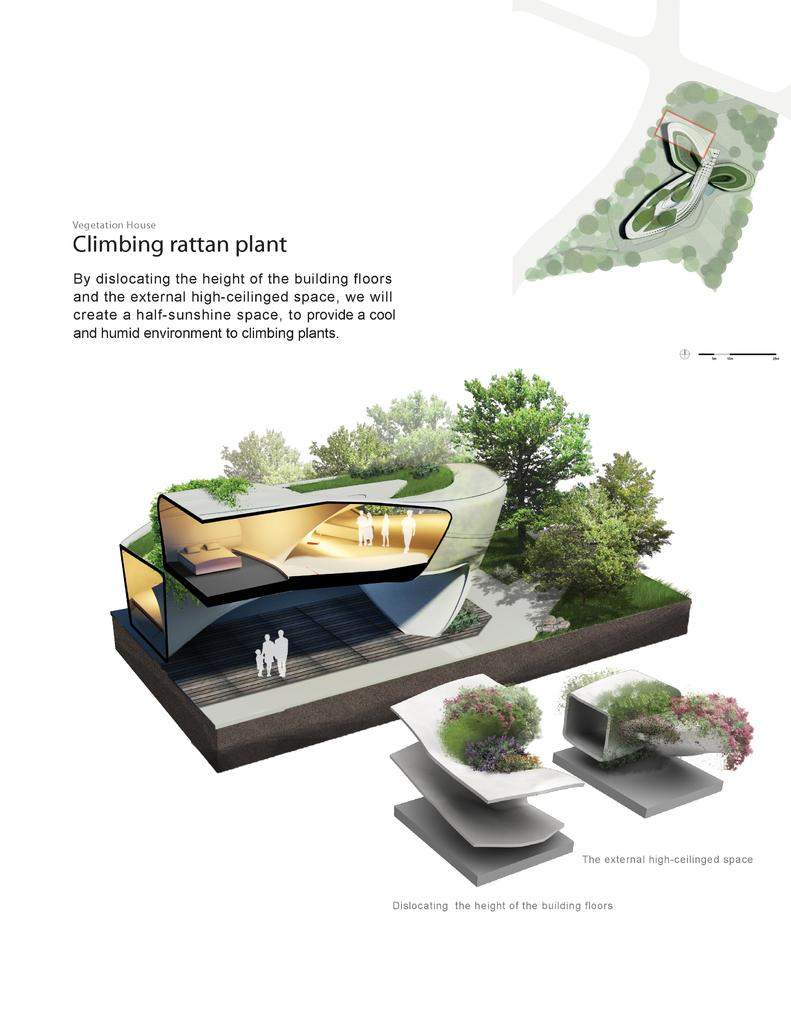What is the main structure in the center of the image? There is a building in the center of the image. What type of natural elements can be seen in the image? There are trees and plants in the image. What else is present in the image besides the building and natural elements? There are some objects in the image. Can you describe the text that is visible in the image? There is text at the top and bottom of the image. Reasoning: Let's think step by breaking down the conversation step by step. We start by identifying the main structure in the image, which is the building. Then, we mention the natural elements present, which are trees and plants. Next, we acknowledge the presence of other objects in the image. Finally, we describe the text that is visible at the top and bottom of the image. Absurd Question/Answer: What type of grass is being used as bait in the image? There is no grass or bait present in the image. What kind of beam is supporting the building in the image? The image does not show the structural support of the building, so it is not possible to determine the type of beam used. 